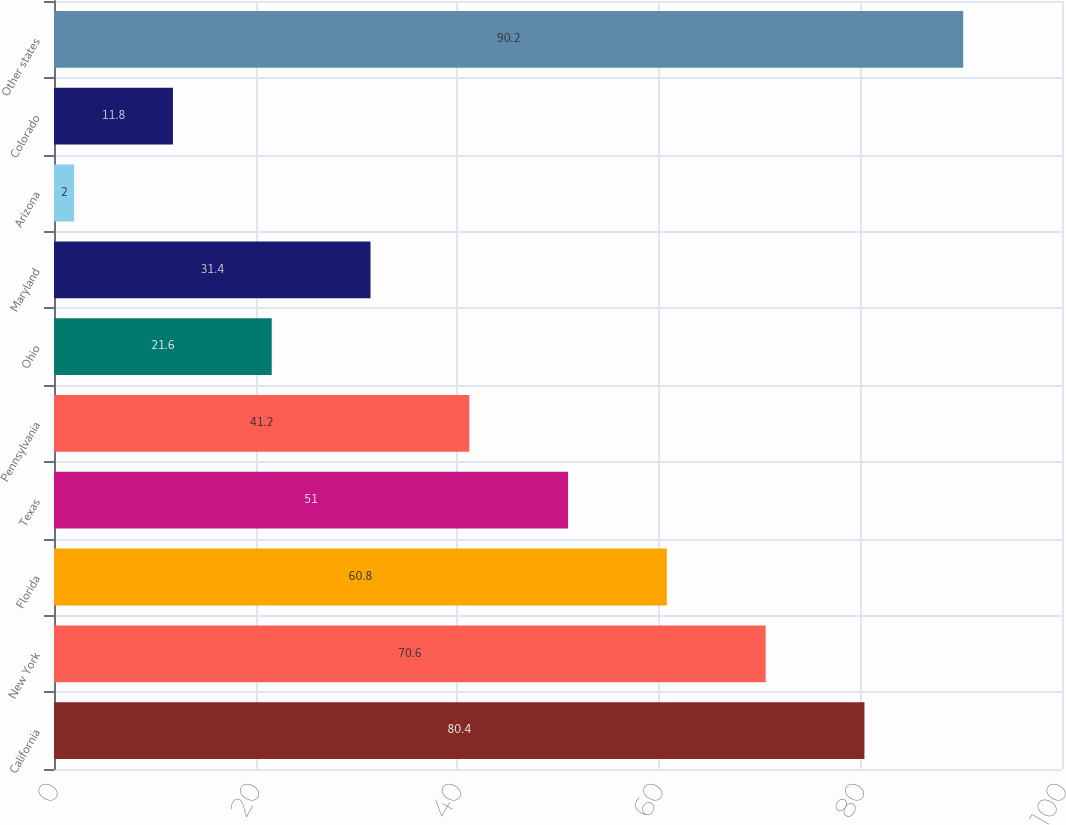<chart> <loc_0><loc_0><loc_500><loc_500><bar_chart><fcel>California<fcel>New York<fcel>Florida<fcel>Texas<fcel>Pennsylvania<fcel>Ohio<fcel>Maryland<fcel>Arizona<fcel>Colorado<fcel>Other states<nl><fcel>80.4<fcel>70.6<fcel>60.8<fcel>51<fcel>41.2<fcel>21.6<fcel>31.4<fcel>2<fcel>11.8<fcel>90.2<nl></chart> 